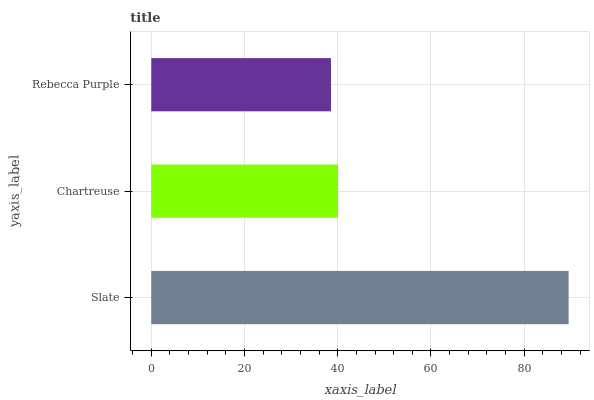Is Rebecca Purple the minimum?
Answer yes or no. Yes. Is Slate the maximum?
Answer yes or no. Yes. Is Chartreuse the minimum?
Answer yes or no. No. Is Chartreuse the maximum?
Answer yes or no. No. Is Slate greater than Chartreuse?
Answer yes or no. Yes. Is Chartreuse less than Slate?
Answer yes or no. Yes. Is Chartreuse greater than Slate?
Answer yes or no. No. Is Slate less than Chartreuse?
Answer yes or no. No. Is Chartreuse the high median?
Answer yes or no. Yes. Is Chartreuse the low median?
Answer yes or no. Yes. Is Slate the high median?
Answer yes or no. No. Is Rebecca Purple the low median?
Answer yes or no. No. 